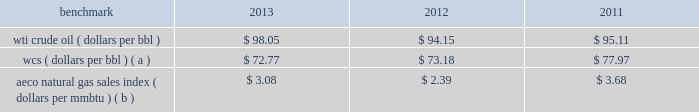Discount to brent was narrower in 2013 than in 2012 and 2011 .
As a result of the significant increase in u.s .
Production of light sweet crude oil , the historical relationship between wti , brent and lls pricing may not be indicative of future periods .
Composition 2013 the proportion of our liquid hydrocarbon sales volumes that are ngls continues to increase due to our development of united states unconventional liquids-rich plays .
Ngls were 15 percent of our north america e&p liquid hydrocarbon sales volumes in 2013 compared to 10 percent in 2012 and 7 percent in 2011 .
Natural gas 2013 a significant portion of our natural gas production in the u.s .
Is sold at bid-week prices , or first-of-month indices relative to our specific producing areas .
Average henry hub settlement prices for natural gas were 31 percent higher for 2013 than for 2012 .
International e&p liquid hydrocarbons 2013 our international e&p crude oil production is relatively sweet and has historically sold in relation to the brent crude benchmark , which on average was 3 percent lower for 2013 than 2012 .
Natural gas 2013 our major international e&p natural gas-producing regions are europe and e.g .
Natural gas prices in europe have been considerably higher than the u.s .
In recent years .
In the case of e.g. , our natural gas sales are subject to term contracts , making realized prices in these areas less volatile .
The natural gas sales from e.g .
Are at fixed prices ; therefore , our reported average international e&p natural gas realized prices may not fully track market price movements .
Oil sands mining the oil sands mining segment produces and sells various qualities of synthetic crude oil .
Output mix can be impacted by operational problems or planned unit outages at the mines or upgrader .
Sales prices for roughly two-thirds of the normal output mix has historically tracked movements in wti and one-third has historically tracked movements in the canadian heavy crude oil marker , primarily wcs .
The wcs discount to wti has been increasing on average in each year presented below .
Despite a wider wcs discount in 2013 , our average oil sands mining price realizations increased due to a greater proportion of higher value synthetic crude oil sales volumes compared to 2012 .
The operating cost structure of the oil sands mining operations is predominantly fixed and therefore many of the costs incurred in times of full operation continue during production downtime .
Per-unit costs are sensitive to production rates .
Key variable costs are natural gas and diesel fuel , which track commodity markets such as the aeco natural gas sales index and crude oil prices , respectively .
The table below shows average benchmark prices that impact both our revenues and variable costs: .
Wcs ( dollars per bbl ) ( a ) $ 72.77 $ 73.18 $ 77.97 aeco natural gas sales index ( dollars per mmbtu ) ( b ) $ 3.08 $ 2.39 $ 3.68 ( a ) monthly pricing based upon average wti adjusted for differentials unique to western canada .
( b ) monthly average day ahead index. .
How much more was the average wti crude price than the wcs price in 2012? 
Computations: (94.15 - 73.18)
Answer: 20.97. 